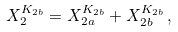Convert formula to latex. <formula><loc_0><loc_0><loc_500><loc_500>X ^ { K _ { 2 b } } _ { 2 } = X ^ { K _ { 2 b } } _ { 2 a } + X ^ { K _ { 2 b } } _ { 2 b } \, ,</formula> 